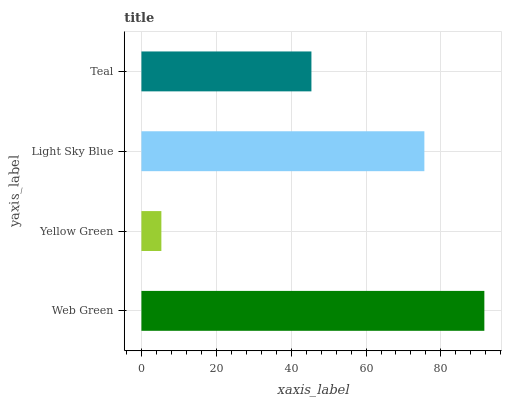Is Yellow Green the minimum?
Answer yes or no. Yes. Is Web Green the maximum?
Answer yes or no. Yes. Is Light Sky Blue the minimum?
Answer yes or no. No. Is Light Sky Blue the maximum?
Answer yes or no. No. Is Light Sky Blue greater than Yellow Green?
Answer yes or no. Yes. Is Yellow Green less than Light Sky Blue?
Answer yes or no. Yes. Is Yellow Green greater than Light Sky Blue?
Answer yes or no. No. Is Light Sky Blue less than Yellow Green?
Answer yes or no. No. Is Light Sky Blue the high median?
Answer yes or no. Yes. Is Teal the low median?
Answer yes or no. Yes. Is Teal the high median?
Answer yes or no. No. Is Yellow Green the low median?
Answer yes or no. No. 